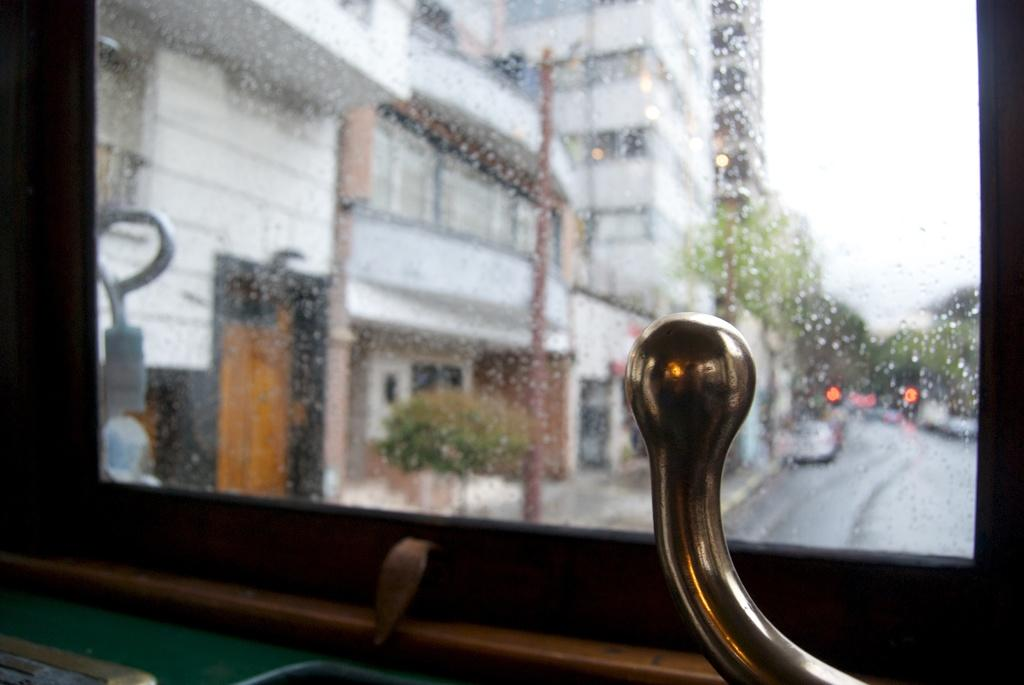What is the medium through which the image is viewed? The image is viewed through a glass. What type of natural environment can be seen in the image? There are trees visible in the image. What type of man-made structure is present in the image? There is at least one building in the image. What type of pathway is visible in the image? There is a road in the image. What type of vertical structures are present in the image? There are poles in the image. What type of moving objects are present in the image? There are vehicles in the image. What part of the natural environment is visible in the image? The sky is visible in the image. What type of quartz can be seen glowing in the image? There is no quartz present in the image, and therefore no such glowing can be observed. How does the person in the image breathe while looking through the glass? A: There is no person visible in the image, so it is not possible to determine how they would breathe. 